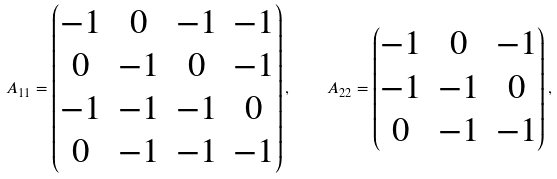Convert formula to latex. <formula><loc_0><loc_0><loc_500><loc_500>A _ { 1 1 } = \begin{pmatrix} - 1 & 0 & - 1 & - 1 \\ 0 & - 1 & 0 & - 1 \\ - 1 & - 1 & - 1 & 0 \\ 0 & - 1 & - 1 & - 1 \end{pmatrix} , \quad A _ { 2 2 } = \begin{pmatrix} - 1 & 0 & - 1 \\ - 1 & - 1 & 0 \\ 0 & - 1 & - 1 \end{pmatrix} ,</formula> 